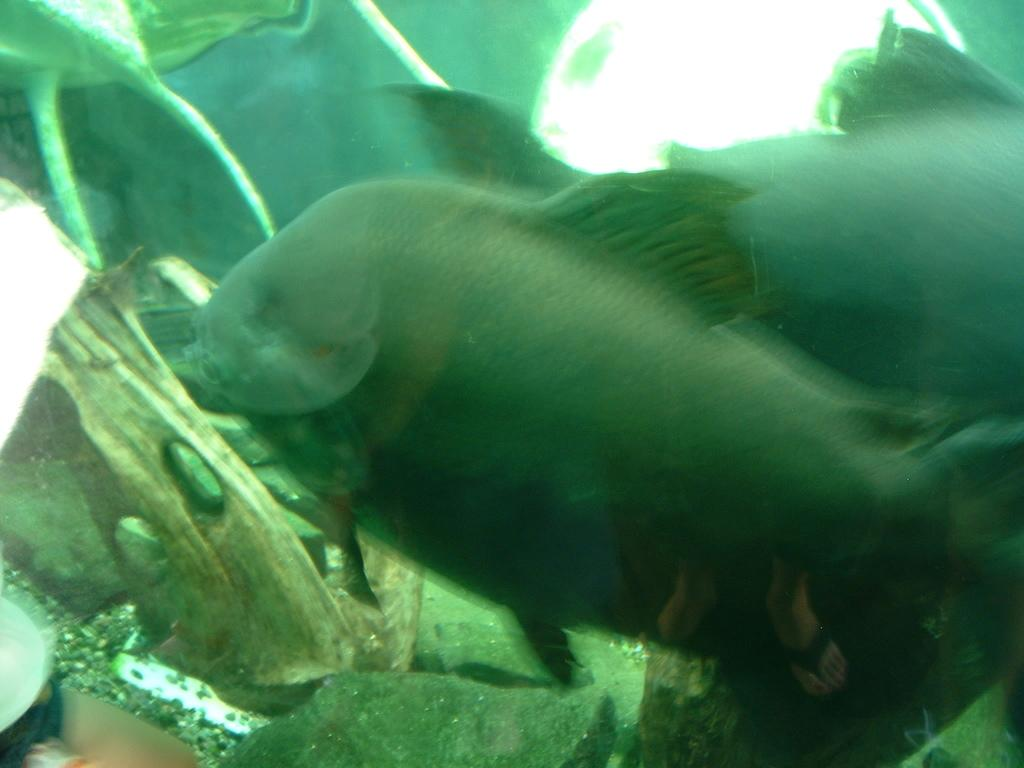What type of animals can be seen in the image? There are fishes in the image. What is present at the bottom of the image? There are stones at the bottom of the image. What might the image be depicting? The image might be of an aquarium. What color is the background of the image? The background of the image is green in color. What type of curtain can be seen hanging in the image? There is no curtain present in the image; it features fishes and stones in an aquarium-like setting. 